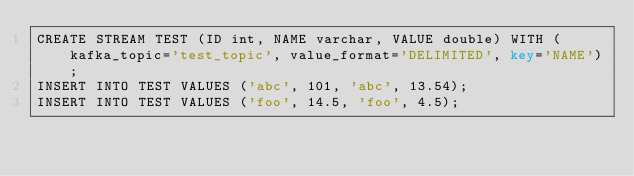Convert code to text. <code><loc_0><loc_0><loc_500><loc_500><_SQL_>CREATE STREAM TEST (ID int, NAME varchar, VALUE double) WITH (kafka_topic='test_topic', value_format='DELIMITED', key='NAME');
INSERT INTO TEST VALUES ('abc', 101, 'abc', 13.54);
INSERT INTO TEST VALUES ('foo', 14.5, 'foo', 4.5);</code> 